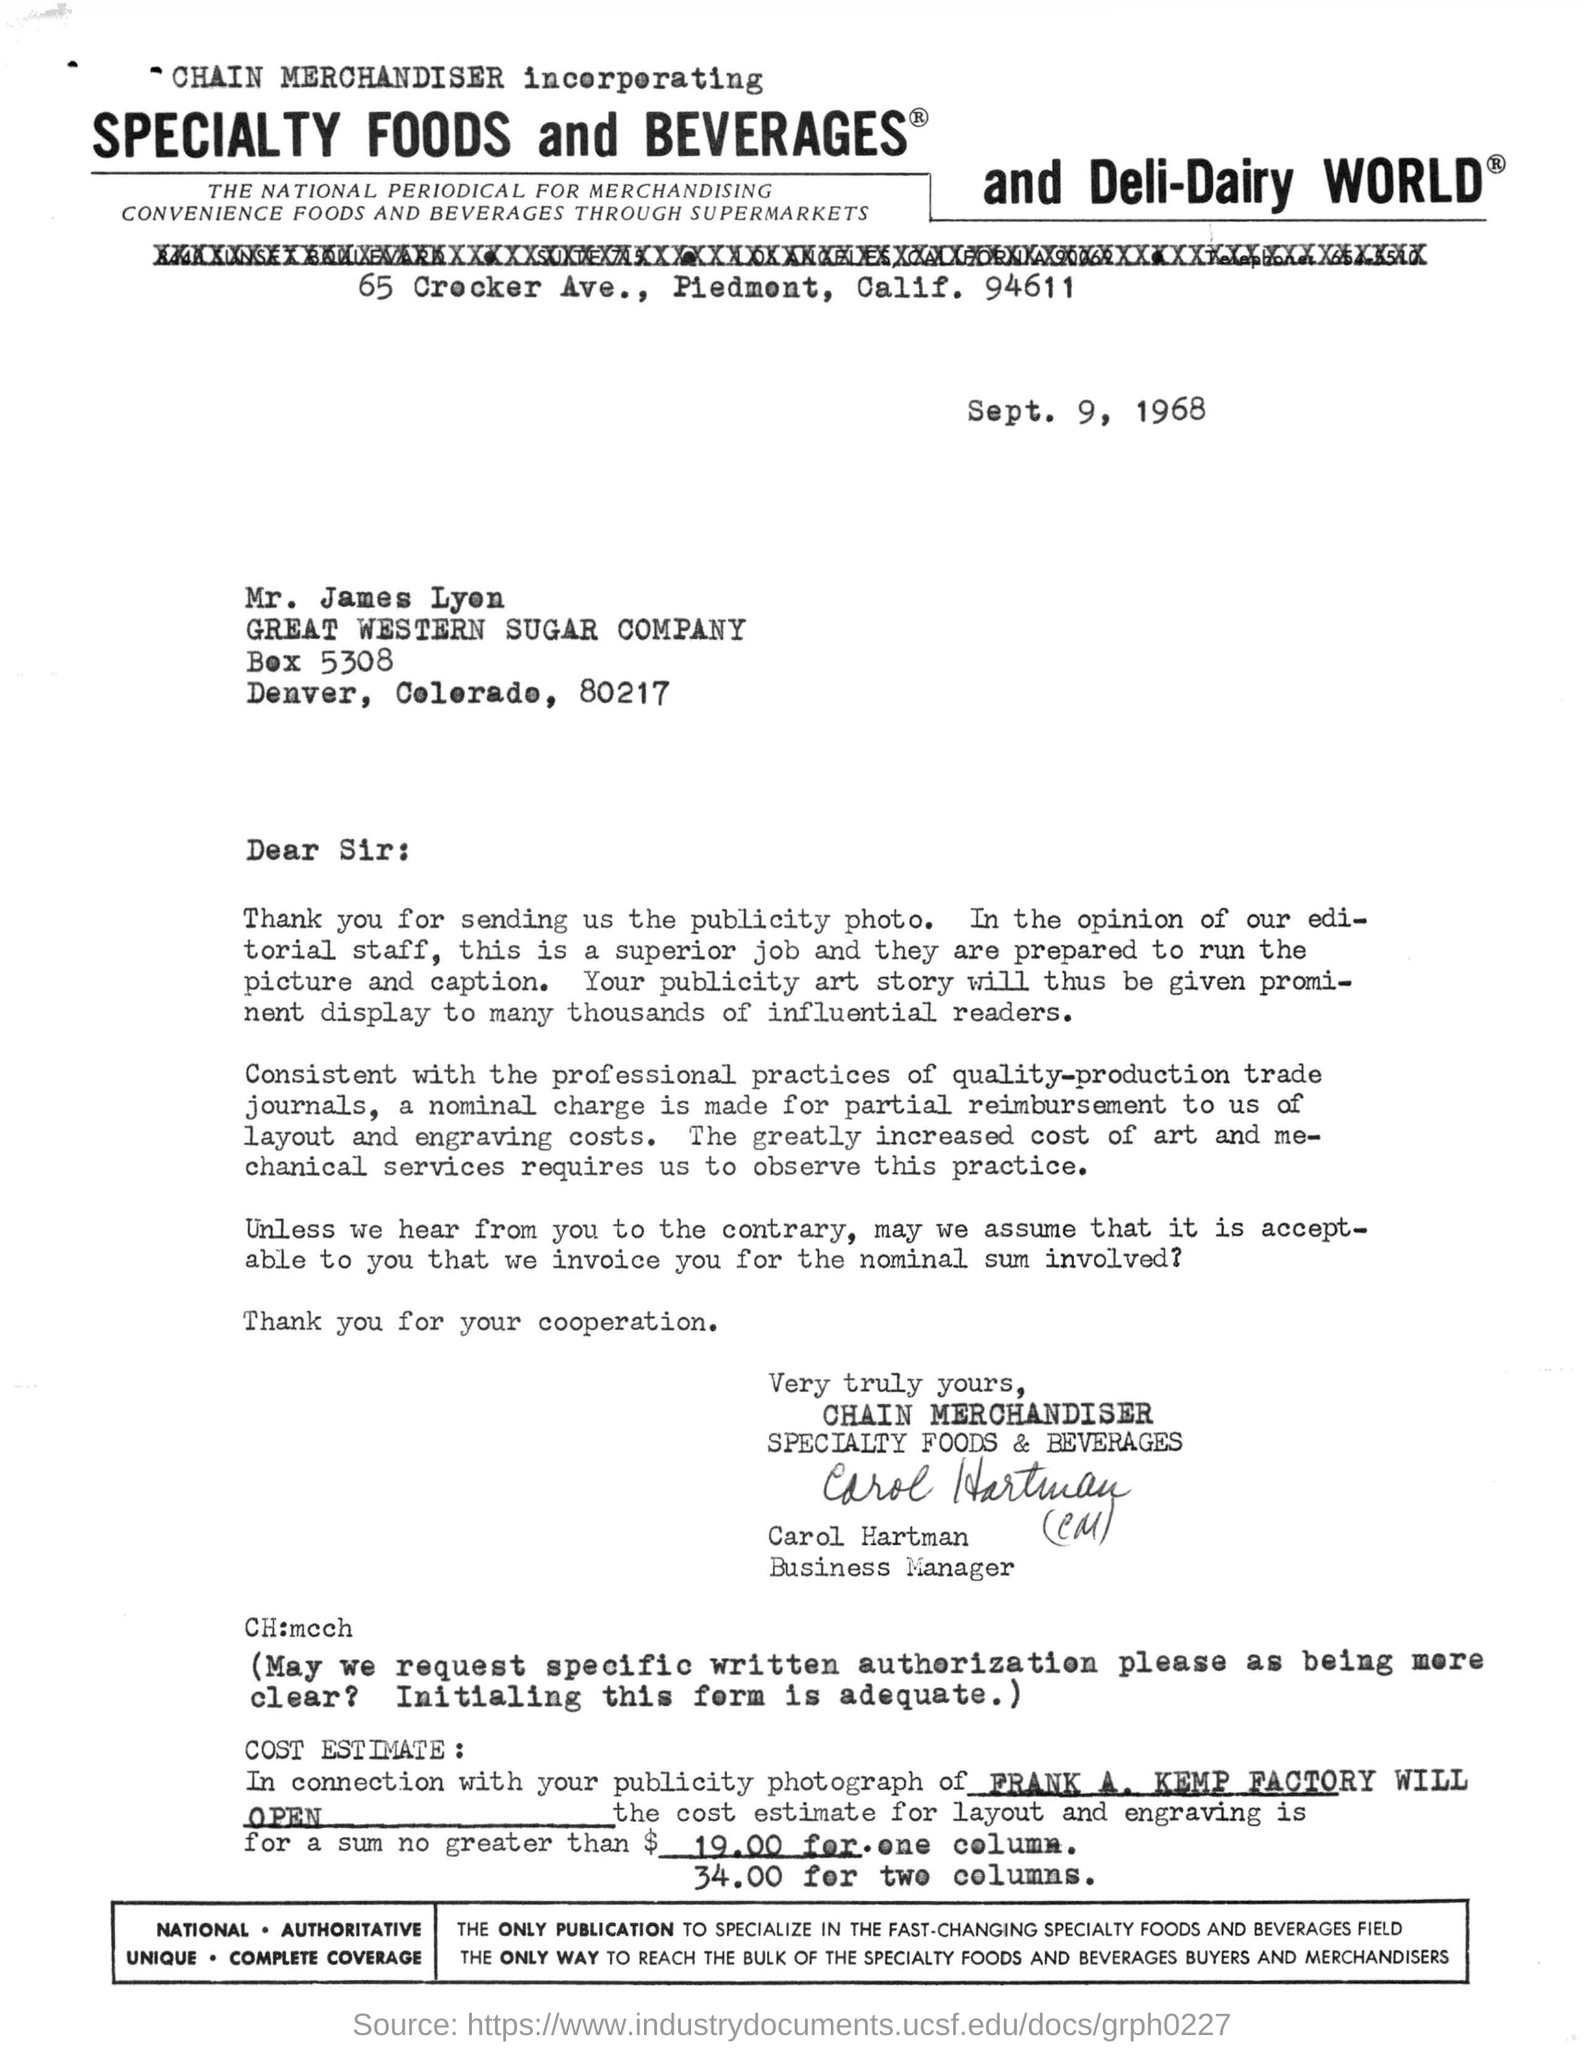Highlight a few significant elements in this photo. This letter was written to Mr. James Lyen. The estimated cost for layout and engraving for one column is $19.00. The estimated cost for layout and engraving for two columns is $34.00. The letter was written on September 9, 1968. The letter has been signed by Carol Hartman. 